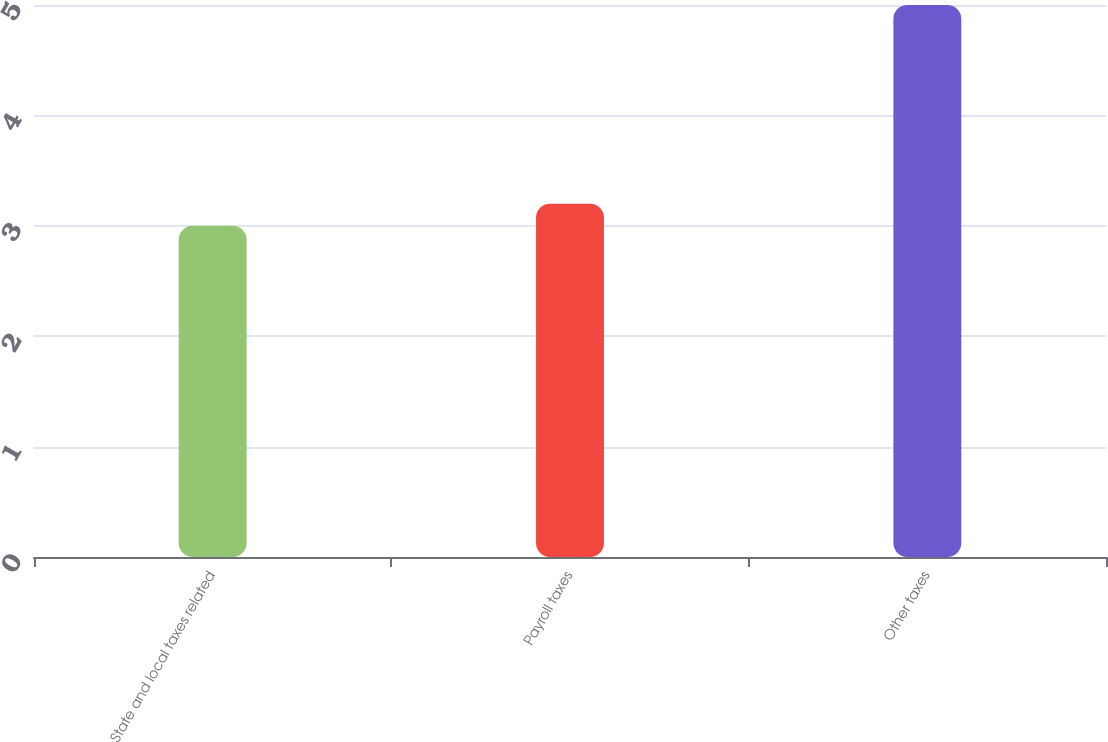<chart> <loc_0><loc_0><loc_500><loc_500><bar_chart><fcel>State and local taxes related<fcel>Payroll taxes<fcel>Other taxes<nl><fcel>3<fcel>3.2<fcel>5<nl></chart> 